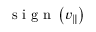<formula> <loc_0><loc_0><loc_500><loc_500>s i g n \left ( v _ { \| } \right )</formula> 